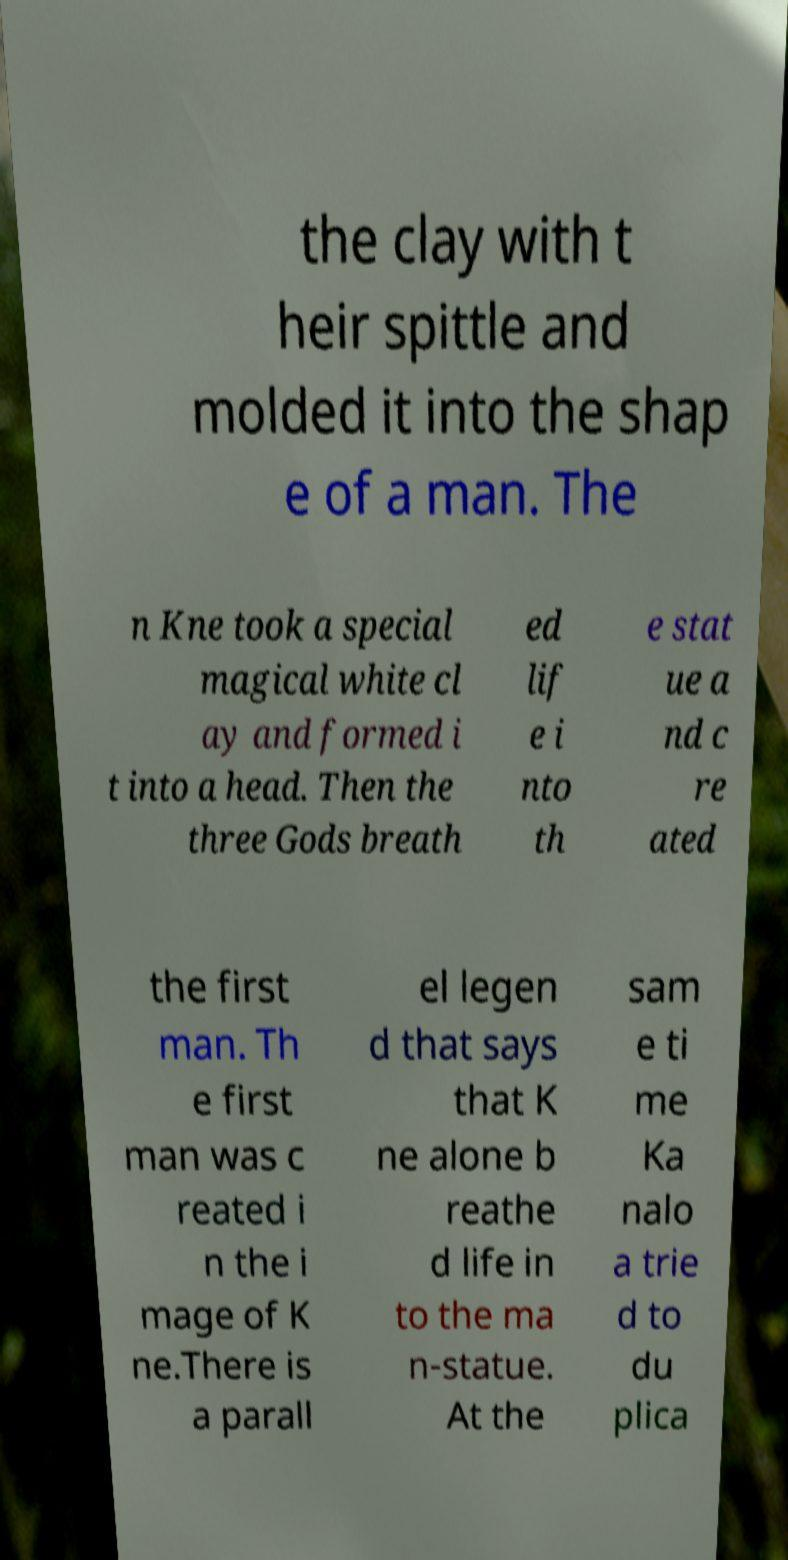Can you read and provide the text displayed in the image?This photo seems to have some interesting text. Can you extract and type it out for me? the clay with t heir spittle and molded it into the shap e of a man. The n Kne took a special magical white cl ay and formed i t into a head. Then the three Gods breath ed lif e i nto th e stat ue a nd c re ated the first man. Th e first man was c reated i n the i mage of K ne.There is a parall el legen d that says that K ne alone b reathe d life in to the ma n-statue. At the sam e ti me Ka nalo a trie d to du plica 